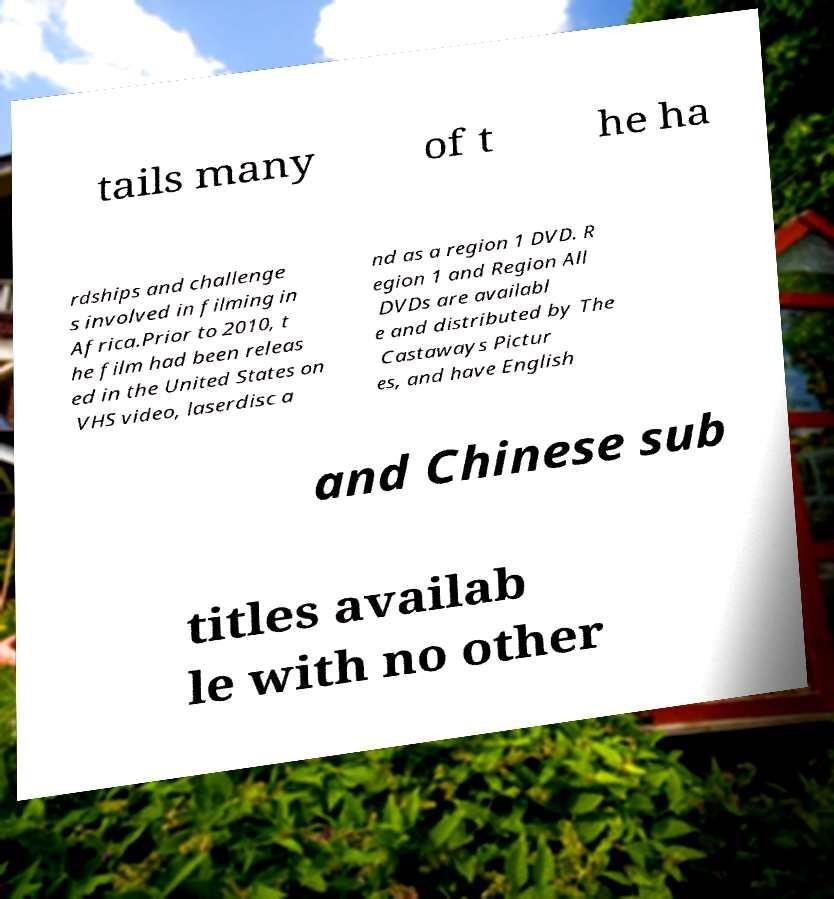Please identify and transcribe the text found in this image. tails many of t he ha rdships and challenge s involved in filming in Africa.Prior to 2010, t he film had been releas ed in the United States on VHS video, laserdisc a nd as a region 1 DVD. R egion 1 and Region All DVDs are availabl e and distributed by The Castaways Pictur es, and have English and Chinese sub titles availab le with no other 